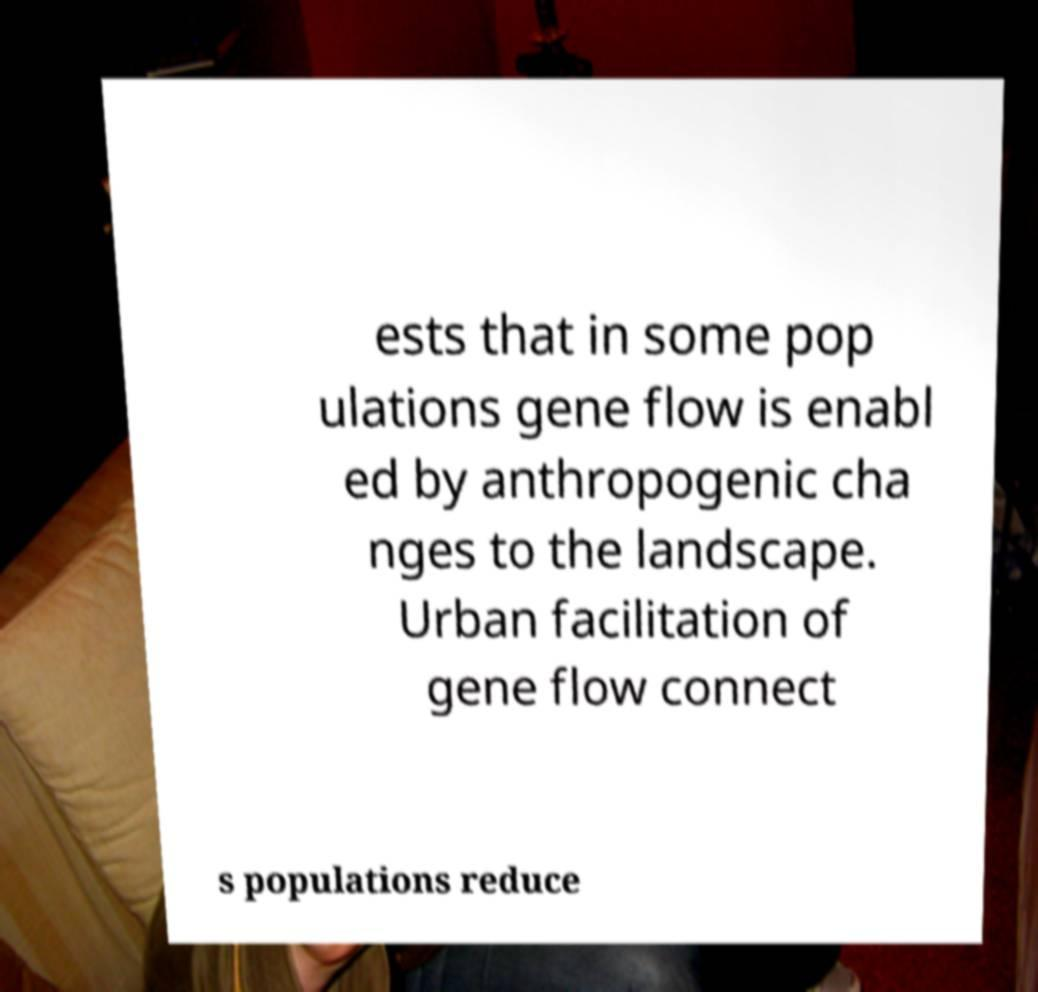Can you read and provide the text displayed in the image?This photo seems to have some interesting text. Can you extract and type it out for me? ests that in some pop ulations gene flow is enabl ed by anthropogenic cha nges to the landscape. Urban facilitation of gene flow connect s populations reduce 